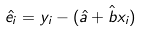<formula> <loc_0><loc_0><loc_500><loc_500>\hat { e _ { i } } = y _ { i } - ( \hat { a } + \hat { b } x _ { i } )</formula> 